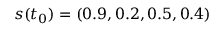Convert formula to latex. <formula><loc_0><loc_0><loc_500><loc_500>s ( t _ { 0 } ) = ( 0 . 9 , 0 . 2 , 0 . 5 , 0 . 4 )</formula> 